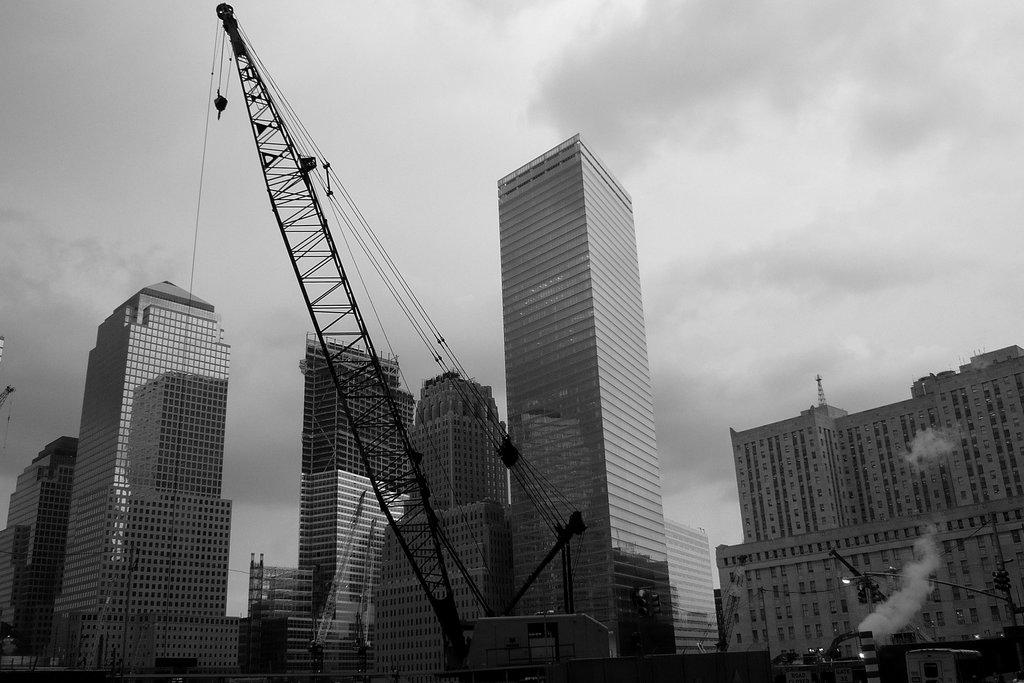What type of structures can be seen in the image? There are many buildings in the image. What is the purpose of the crane in the image? The crane has a rope, which suggests it is being used for lifting or moving objects. Can you describe the weather conditions in the image? The sky is cloudy in the image. What is the presence of smoke in the image indicative of? The presence of smoke in the image suggests that there may be some construction or industrial activity taking place. What type of reaction can be seen between the spoon and the buildings in the image? There is no spoon present in the image, so no such reaction can be observed. 